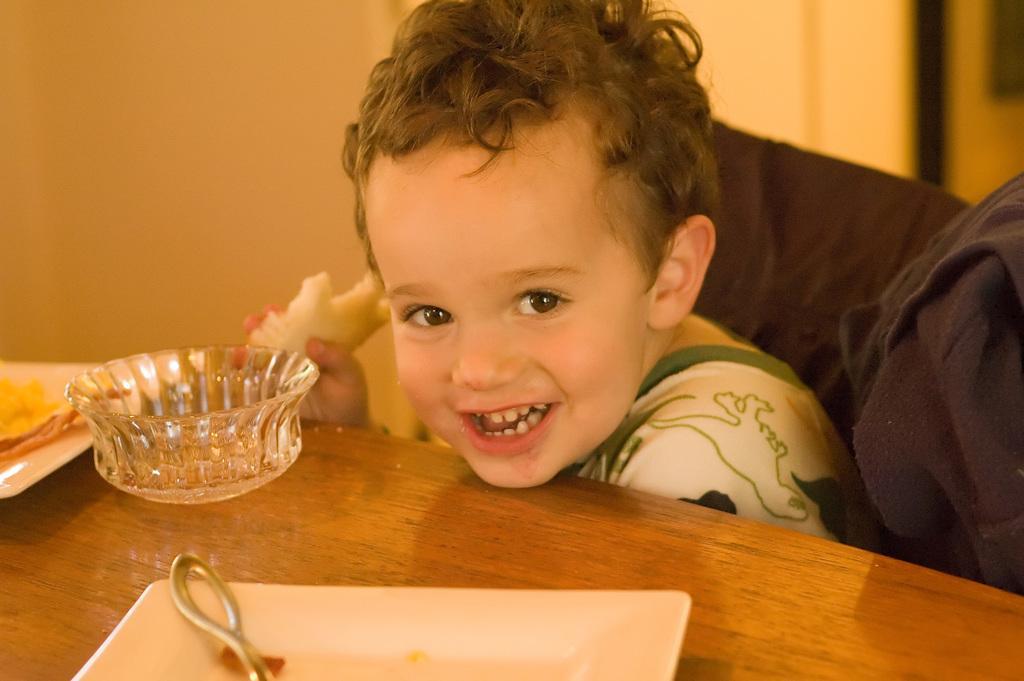Could you give a brief overview of what you see in this image? In this picture I can see a baby sitting in front of the table, on which I can see some object are placed. 